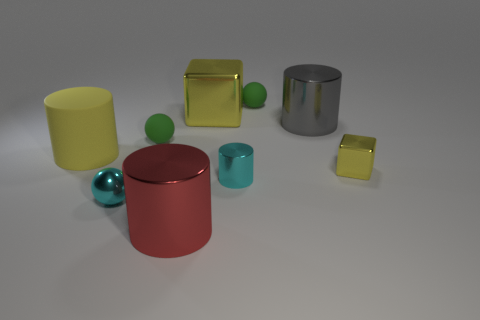Subtract 1 cylinders. How many cylinders are left? 3 Add 1 large cubes. How many objects exist? 10 Subtract all spheres. How many objects are left? 6 Subtract 0 purple balls. How many objects are left? 9 Subtract all small shiny balls. Subtract all tiny yellow objects. How many objects are left? 7 Add 5 tiny yellow cubes. How many tiny yellow cubes are left? 6 Add 9 small brown metal cubes. How many small brown metal cubes exist? 9 